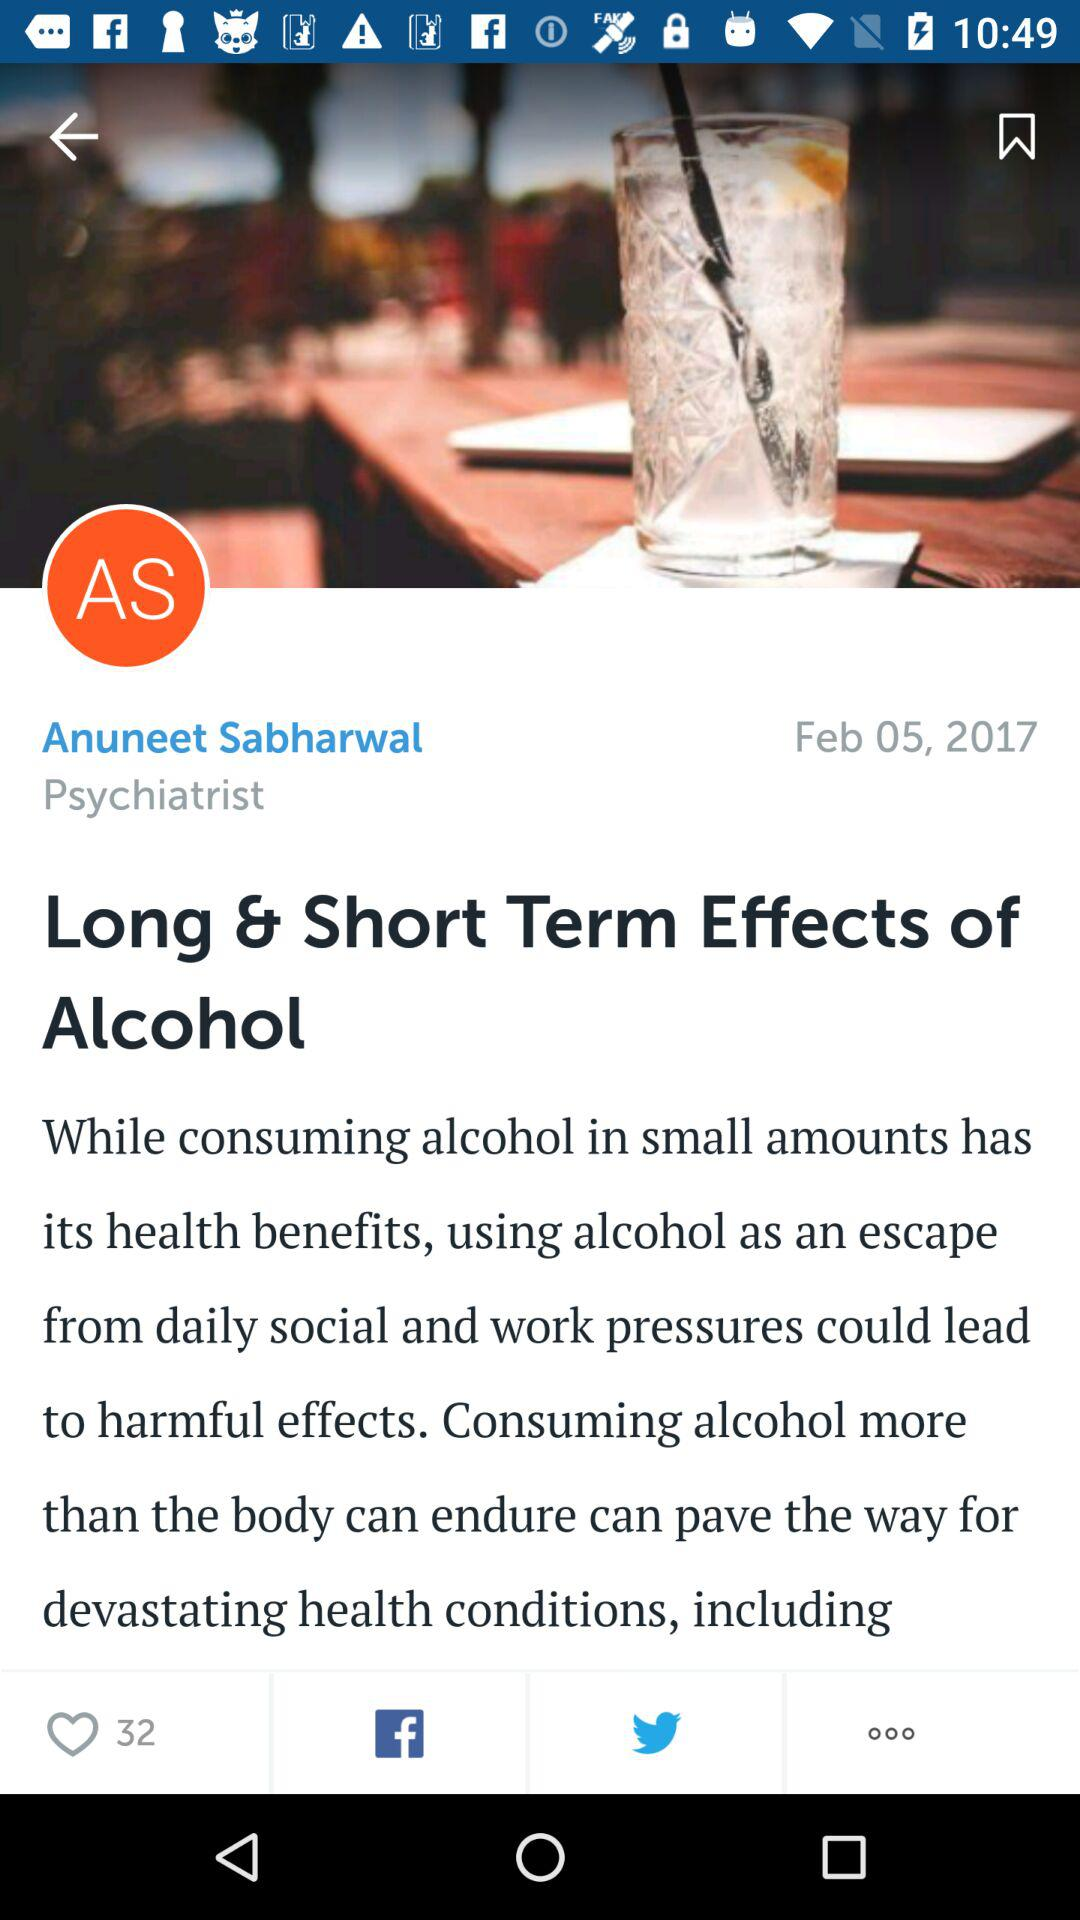How many likes are there? There are 32 likes. 